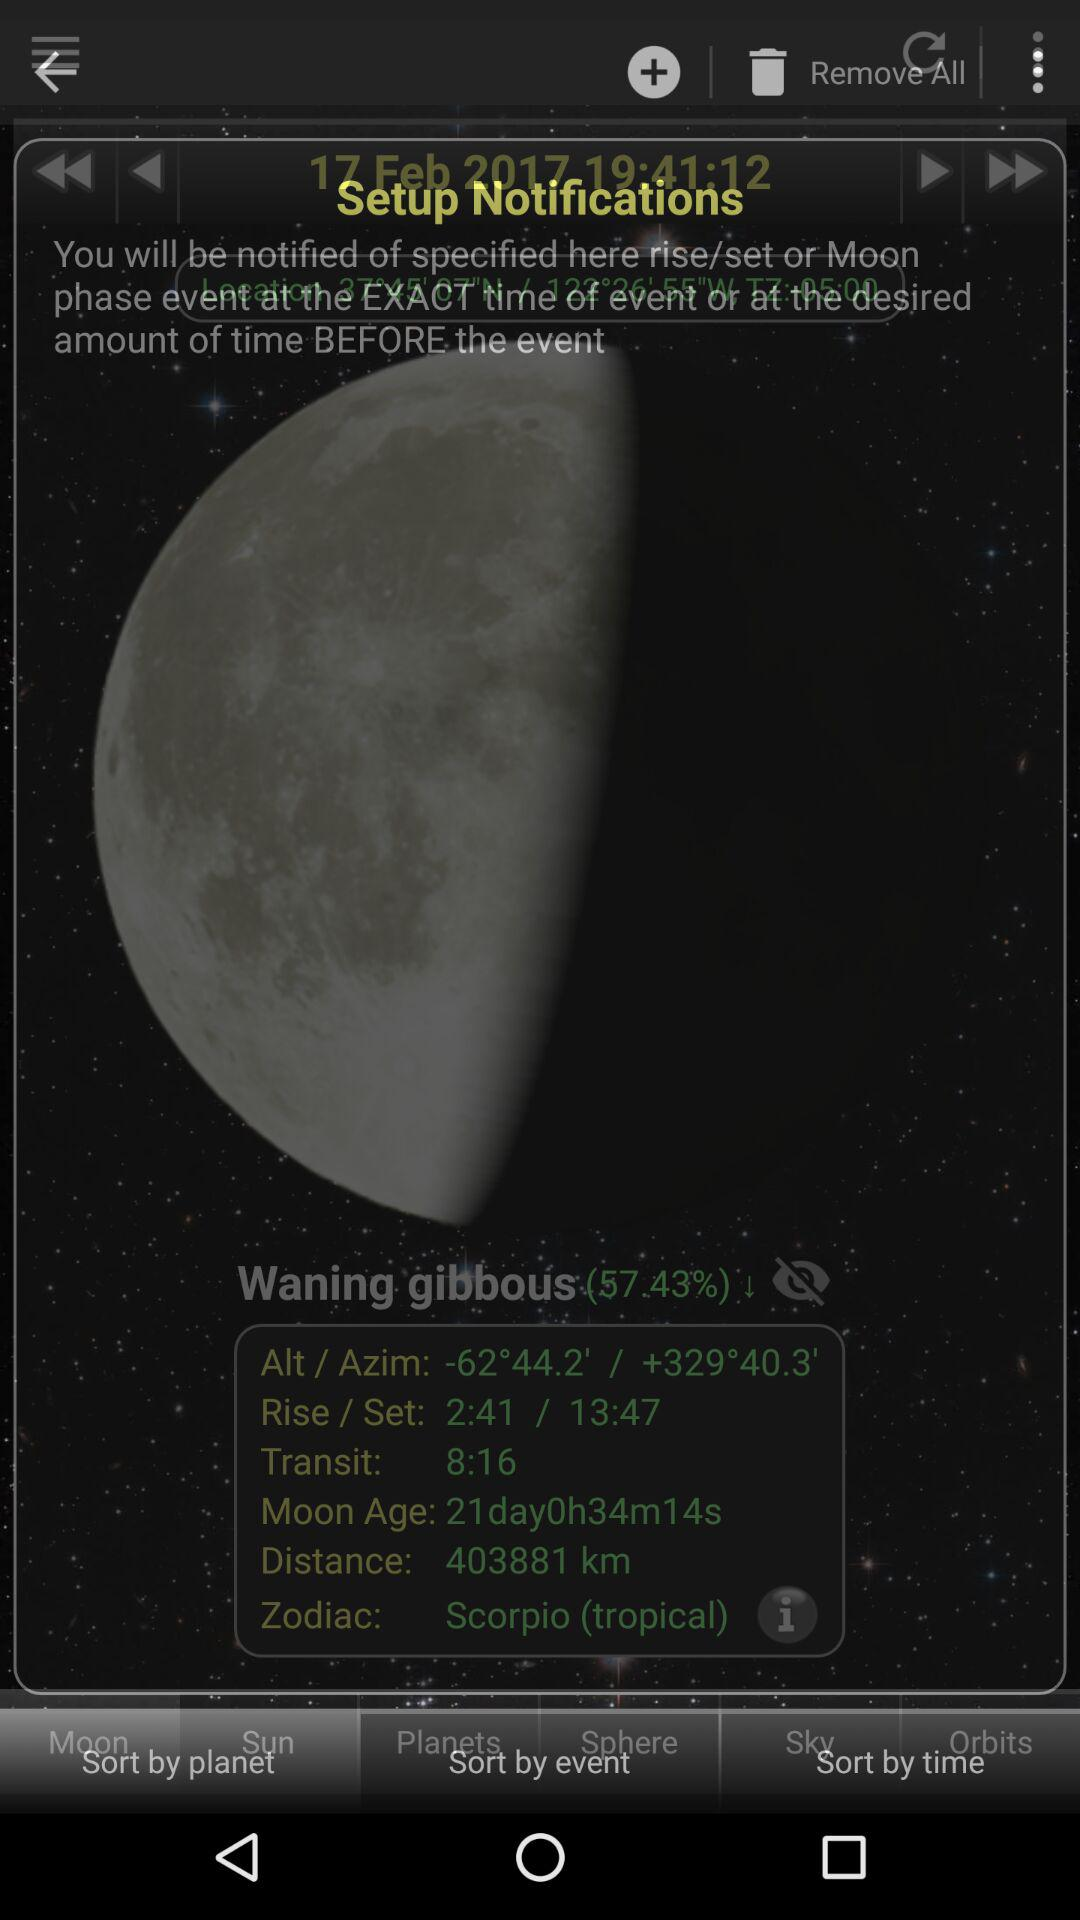What is the date and time? The date and time are February 17, 2017 and 19 hours 41 minutes 12 seconds. 